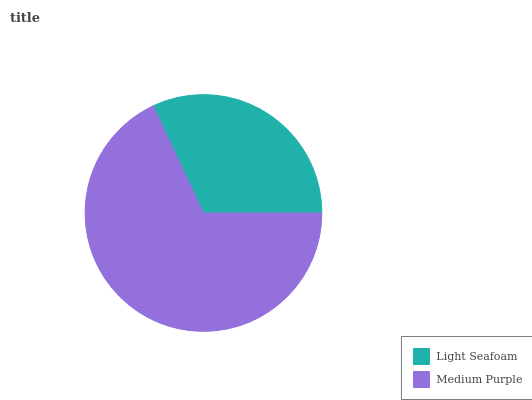Is Light Seafoam the minimum?
Answer yes or no. Yes. Is Medium Purple the maximum?
Answer yes or no. Yes. Is Medium Purple the minimum?
Answer yes or no. No. Is Medium Purple greater than Light Seafoam?
Answer yes or no. Yes. Is Light Seafoam less than Medium Purple?
Answer yes or no. Yes. Is Light Seafoam greater than Medium Purple?
Answer yes or no. No. Is Medium Purple less than Light Seafoam?
Answer yes or no. No. Is Medium Purple the high median?
Answer yes or no. Yes. Is Light Seafoam the low median?
Answer yes or no. Yes. Is Light Seafoam the high median?
Answer yes or no. No. Is Medium Purple the low median?
Answer yes or no. No. 